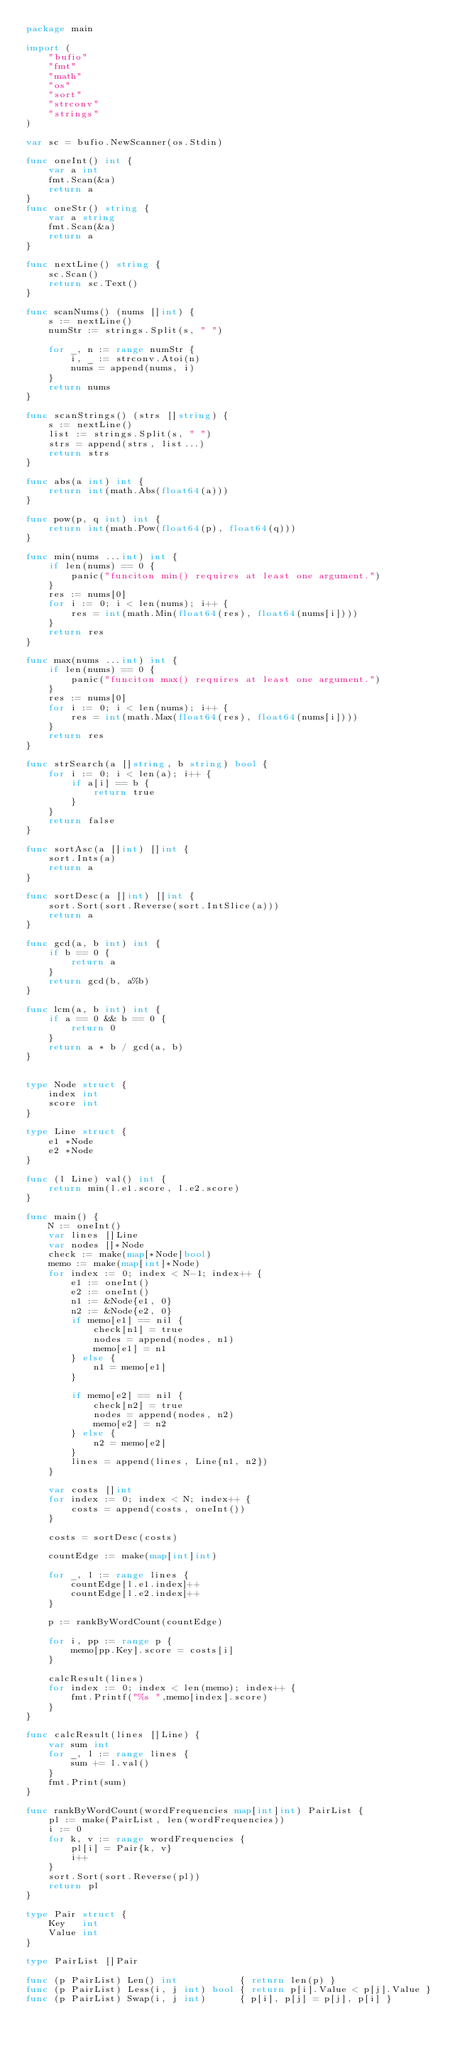Convert code to text. <code><loc_0><loc_0><loc_500><loc_500><_Go_>package main

import (
	"bufio"
	"fmt"
	"math"
	"os"
	"sort"
	"strconv"
	"strings"
)

var sc = bufio.NewScanner(os.Stdin)

func oneInt() int {
	var a int
	fmt.Scan(&a)
	return a
}
func oneStr() string {
	var a string
	fmt.Scan(&a)
	return a
}

func nextLine() string {
	sc.Scan()
	return sc.Text()
}

func scanNums() (nums []int) {
	s := nextLine()
	numStr := strings.Split(s, " ")

	for _, n := range numStr {
		i, _ := strconv.Atoi(n)
		nums = append(nums, i)
	}
	return nums
}

func scanStrings() (strs []string) {
	s := nextLine()
	list := strings.Split(s, " ")
	strs = append(strs, list...)
	return strs
}

func abs(a int) int {
	return int(math.Abs(float64(a)))
}

func pow(p, q int) int {
	return int(math.Pow(float64(p), float64(q)))
}

func min(nums ...int) int {
	if len(nums) == 0 {
		panic("funciton min() requires at least one argument.")
	}
	res := nums[0]
	for i := 0; i < len(nums); i++ {
		res = int(math.Min(float64(res), float64(nums[i])))
	}
	return res
}

func max(nums ...int) int {
	if len(nums) == 0 {
		panic("funciton max() requires at least one argument.")
	}
	res := nums[0]
	for i := 0; i < len(nums); i++ {
		res = int(math.Max(float64(res), float64(nums[i])))
	}
	return res
}

func strSearch(a []string, b string) bool {
	for i := 0; i < len(a); i++ {
		if a[i] == b {
			return true
		}
	}
	return false
}

func sortAsc(a []int) []int {
	sort.Ints(a)
	return a
}

func sortDesc(a []int) []int {
	sort.Sort(sort.Reverse(sort.IntSlice(a)))
	return a
}

func gcd(a, b int) int {
	if b == 0 {
		return a
	}
	return gcd(b, a%b)
}

func lcm(a, b int) int {
	if a == 0 && b == 0 {
		return 0
	}
	return a * b / gcd(a, b)
}


type Node struct {
	index int
	score int
}

type Line struct {
	e1 *Node
	e2 *Node
}

func (l Line) val() int {
	return min(l.e1.score, l.e2.score)
}

func main() {
	N := oneInt()
	var lines []Line
	var nodes []*Node
	check := make(map[*Node]bool)
	memo := make(map[int]*Node)
	for index := 0; index < N-1; index++ {
		e1 := oneInt()
		e2 := oneInt()
		n1 := &Node{e1, 0}
		n2 := &Node{e2, 0}
		if memo[e1] == nil {
			check[n1] = true
			nodes = append(nodes, n1)
			memo[e1] = n1
		} else {
			n1 = memo[e1]
		}

		if memo[e2] == nil {
			check[n2] = true
			nodes = append(nodes, n2)
			memo[e2] = n2
		} else {
			n2 = memo[e2]
		}
		lines = append(lines, Line{n1, n2})
	}

	var costs []int
	for index := 0; index < N; index++ {
		costs = append(costs, oneInt())
	}

	costs = sortDesc(costs)

	countEdge := make(map[int]int)

	for _, l := range lines {
		countEdge[l.e1.index]++
		countEdge[l.e2.index]++
	}

	p := rankByWordCount(countEdge)

	for i, pp := range p {
		memo[pp.Key].score = costs[i]
	}

	calcResult(lines)
	for index := 0; index < len(memo); index++ {
		fmt.Printf("%s ",memo[index].score)
	}
}

func calcResult(lines []Line) {
	var sum int
	for _, l := range lines {
		sum += l.val()
	}
	fmt.Print(sum)
}

func rankByWordCount(wordFrequencies map[int]int) PairList {
	pl := make(PairList, len(wordFrequencies))
	i := 0
	for k, v := range wordFrequencies {
		pl[i] = Pair{k, v}
		i++
	}
	sort.Sort(sort.Reverse(pl))
	return pl
}

type Pair struct {
	Key   int
	Value int
}

type PairList []Pair

func (p PairList) Len() int           { return len(p) }
func (p PairList) Less(i, j int) bool { return p[i].Value < p[j].Value }
func (p PairList) Swap(i, j int)      { p[i], p[j] = p[j], p[i] }
</code> 